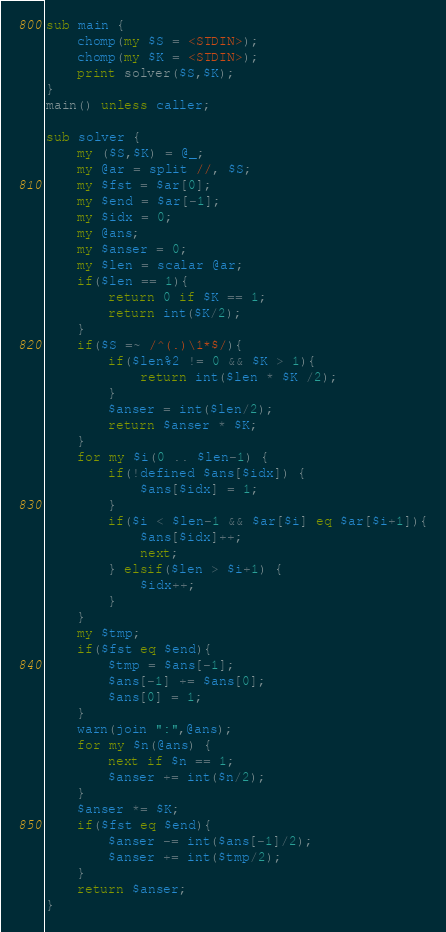<code> <loc_0><loc_0><loc_500><loc_500><_Perl_>sub main {
    chomp(my $S = <STDIN>);
    chomp(my $K = <STDIN>);
    print solver($S,$K);
}
main() unless caller;

sub solver {
    my ($S,$K) = @_;
    my @ar = split //, $S;
    my $fst = $ar[0];
    my $end = $ar[-1];
    my $idx = 0;
    my @ans;
    my $anser = 0;
    my $len = scalar @ar;
    if($len == 1){
        return 0 if $K == 1;
        return int($K/2);
    }
    if($S =~ /^(.)\1*$/){
        if($len%2 != 0 && $K > 1){
            return int($len * $K /2);
        }
        $anser = int($len/2);
        return $anser * $K;
    }
    for my $i(0 .. $len-1) {
        if(!defined $ans[$idx]) {
            $ans[$idx] = 1;
        }
        if($i < $len-1 && $ar[$i] eq $ar[$i+1]){
            $ans[$idx]++;
            next;
        } elsif($len > $i+1) {
            $idx++;
        }
    }
    my $tmp;
    if($fst eq $end){
        $tmp = $ans[-1];
        $ans[-1] += $ans[0];
        $ans[0] = 1;
    }
    warn(join ":",@ans);
    for my $n(@ans) {
        next if $n == 1;
        $anser += int($n/2);
    }
    $anser *= $K;
    if($fst eq $end){
        $anser -= int($ans[-1]/2);
        $anser += int($tmp/2);
    }
    return $anser;
}</code> 